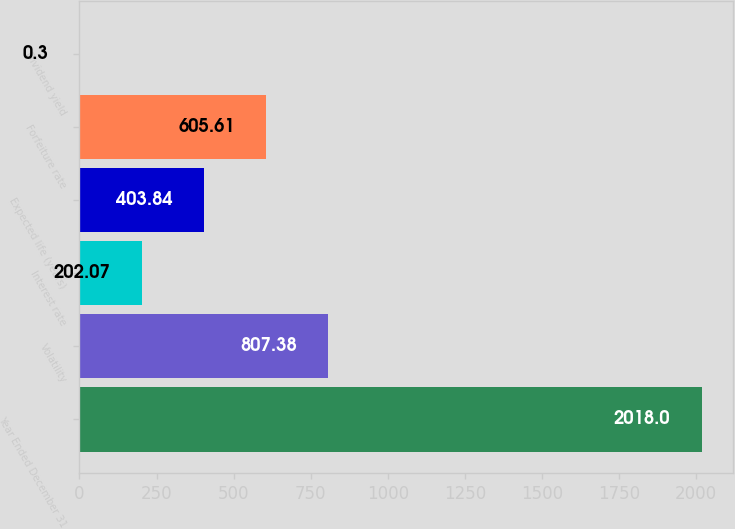Convert chart to OTSL. <chart><loc_0><loc_0><loc_500><loc_500><bar_chart><fcel>Year Ended December 31<fcel>Volatility<fcel>Interest rate<fcel>Expected life (years)<fcel>Forfeiture rate<fcel>Dividend yield<nl><fcel>2018<fcel>807.38<fcel>202.07<fcel>403.84<fcel>605.61<fcel>0.3<nl></chart> 